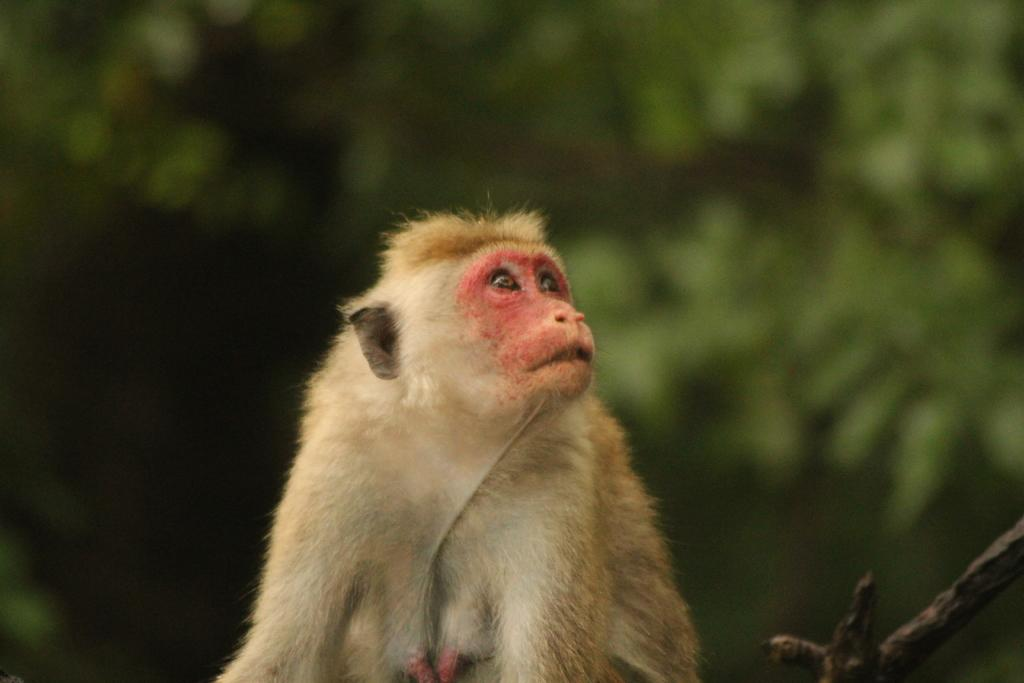What animal is present in the image? There is a monkey in the image. What colors can be seen on the monkey? The monkey is brown and white in color. What colors are present in the background of the image? The background of the image is green and black. How does the monkey express its feelings in the image? The image does not show the monkey expressing any feelings, as it is a still image and does not depict emotions. 